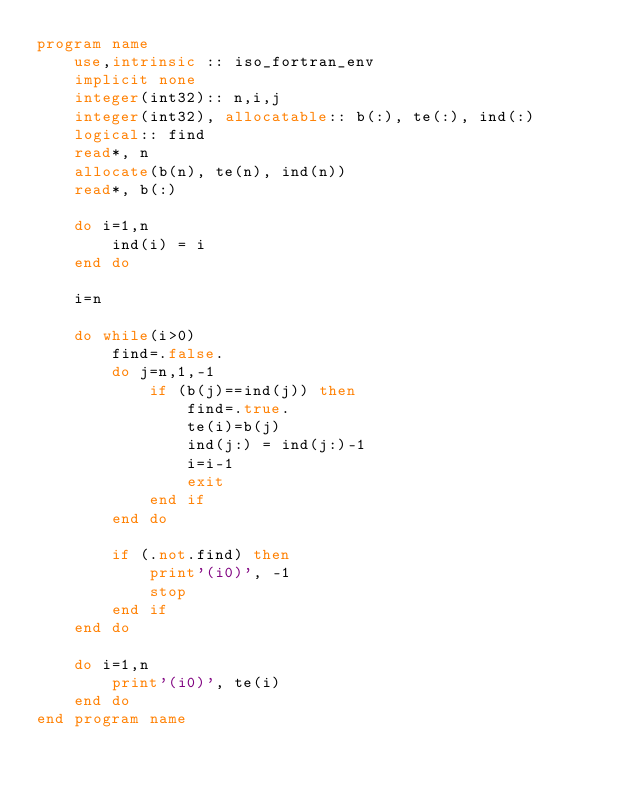Convert code to text. <code><loc_0><loc_0><loc_500><loc_500><_FORTRAN_>program name
    use,intrinsic :: iso_fortran_env
    implicit none
    integer(int32):: n,i,j
    integer(int32), allocatable:: b(:), te(:), ind(:)
    logical:: find
    read*, n
    allocate(b(n), te(n), ind(n))
    read*, b(:)

    do i=1,n
        ind(i) = i
    end do

    i=n

    do while(i>0)
        find=.false.
        do j=n,1,-1
            if (b(j)==ind(j)) then
                find=.true.
                te(i)=b(j)
                ind(j:) = ind(j:)-1
                i=i-1
                exit
            end if
        end do

        if (.not.find) then
            print'(i0)', -1
            stop
        end if
    end do

    do i=1,n
        print'(i0)', te(i)
    end do
end program name</code> 